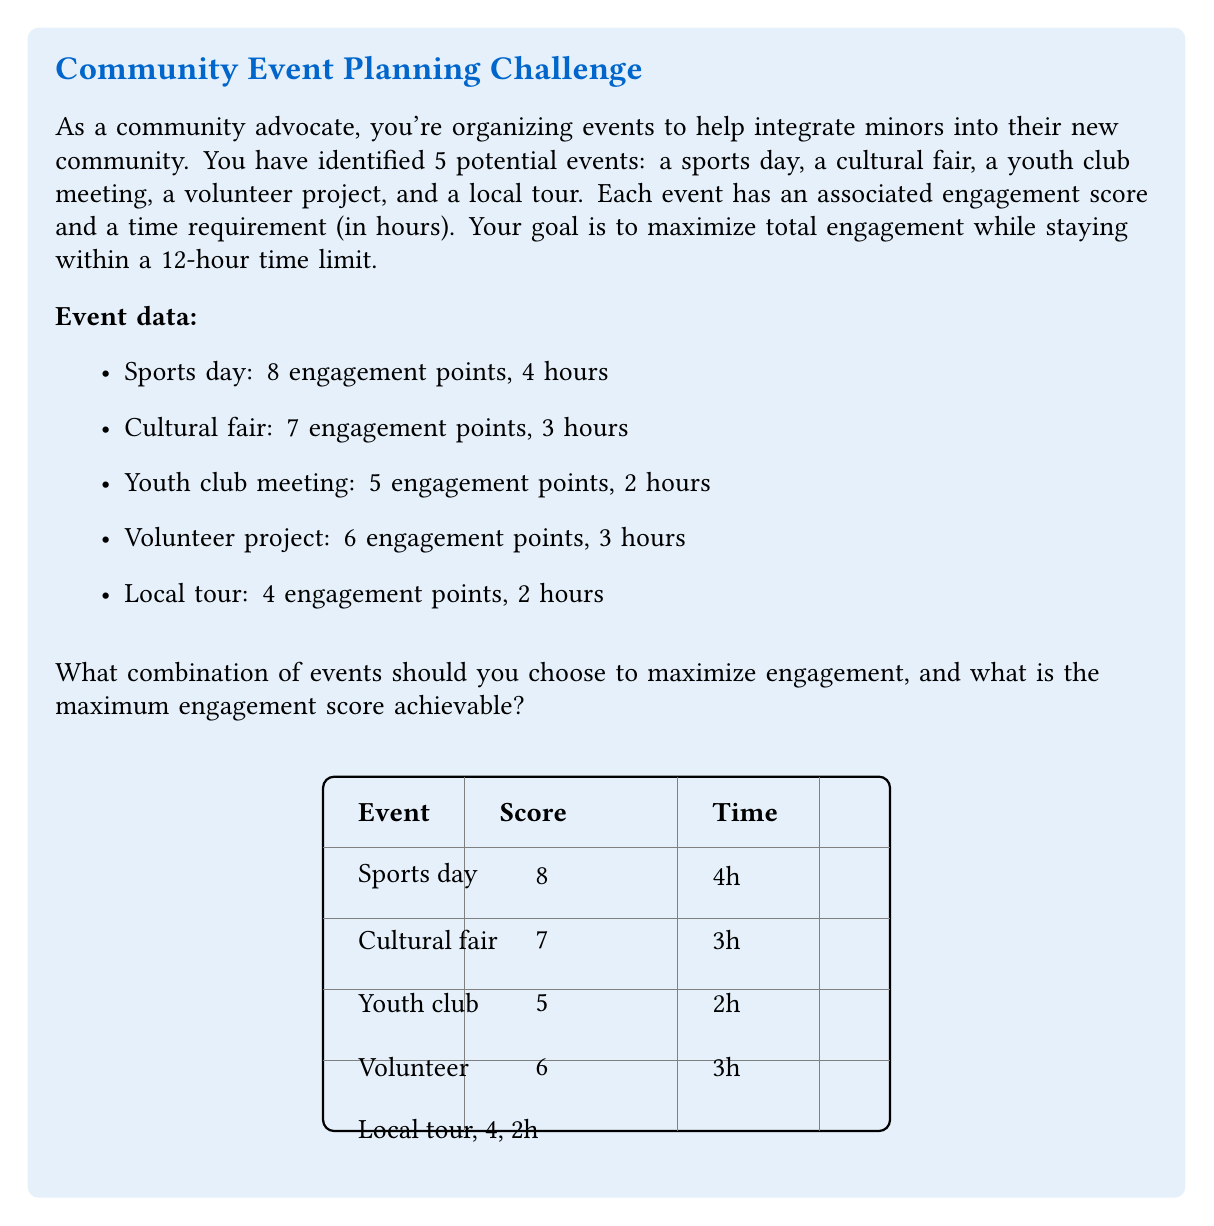What is the answer to this math problem? To solve this optimization problem, we can use the 0-1 Knapsack algorithm. Let's approach this step-by-step:

1) First, let's define our variables:
   $x_i$ = 1 if event i is chosen, 0 otherwise
   $v_i$ = engagement score of event i
   $t_i$ = time required for event i

2) Our objective function is to maximize total engagement:
   $\text{Maximize } \sum_{i=1}^5 v_i x_i$

3) Subject to the time constraint:
   $\sum_{i=1}^5 t_i x_i \leq 12$

4) We can solve this using dynamic programming. Let's create a table where rows represent events and columns represent time from 0 to 12 hours.

5) Fill the table:
   - If the current event doesn't fit in the current time, copy the value from the row above.
   - If it does fit, take the maximum of:
     a) The value from the row above (not including this event)
     b) The value of this event plus the best value achievable with the remaining time

6) After filling the table, the bottom-right cell gives us the maximum achievable engagement score.

7) To find which events to include, we backtrack from this cell:
   - If the value comes from the cell above, we don't include this event.
   - If it's different, we include this event and move to the cell representing the remaining time.

8) Following this process, we find that the optimal solution is to include:
   - Sports day (8 points, 4 hours)
   - Cultural fair (7 points, 3 hours)
   - Youth club meeting (5 points, 2 hours)

9) This combination gives a total engagement score of $8 + 7 + 5 = 20$ and takes $4 + 3 + 2 = 9$ hours, which is within our 12-hour limit.
Answer: Choose Sports day, Cultural fair, and Youth club meeting. Maximum engagement score: 20. 